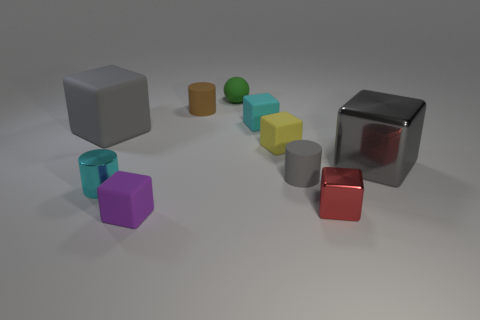What is the shape of the shiny thing that is the same size as the metal cylinder?
Your response must be concise. Cube. What number of other objects are the same color as the big shiny cube?
Provide a short and direct response. 2. What number of other things are made of the same material as the tiny brown thing?
Your answer should be very brief. 6. There is a yellow matte cube; does it have the same size as the gray object that is left of the green object?
Make the answer very short. No. What is the color of the small ball?
Provide a short and direct response. Green. The gray matte object that is in front of the big gray object that is behind the gray block on the right side of the tiny cyan shiny thing is what shape?
Give a very brief answer. Cylinder. What is the material of the gray object that is in front of the big thing to the right of the tiny cyan shiny object?
Your answer should be very brief. Rubber. There is a gray object that is the same material as the small red object; what shape is it?
Your answer should be compact. Cube. Are there any other things that are the same shape as the small cyan metallic thing?
Offer a terse response. Yes. How many tiny brown rubber things are to the left of the purple matte cube?
Ensure brevity in your answer.  0. 